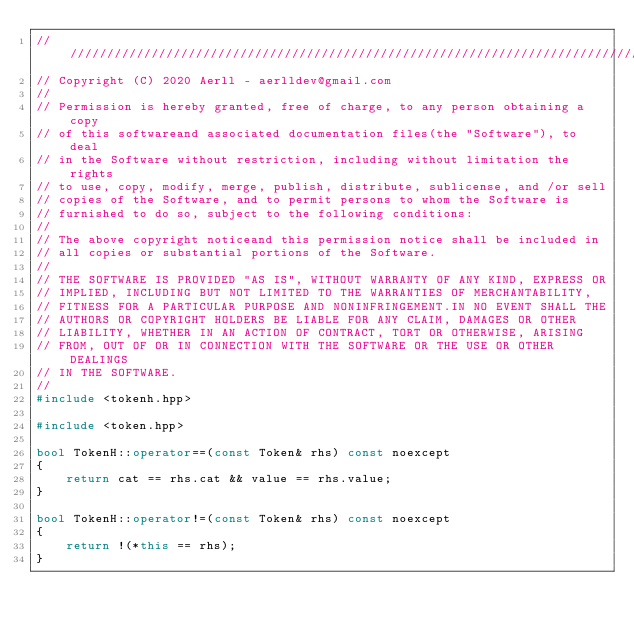<code> <loc_0><loc_0><loc_500><loc_500><_C++_>///////////////////////////////////////////////////////////////////////////////
// Copyright (C) 2020 Aerll - aerlldev@gmail.com
// 
// Permission is hereby granted, free of charge, to any person obtaining a copy
// of this softwareand associated documentation files(the "Software"), to deal
// in the Software without restriction, including without limitation the rights
// to use, copy, modify, merge, publish, distribute, sublicense, and /or sell
// copies of the Software, and to permit persons to whom the Software is
// furnished to do so, subject to the following conditions:
// 
// The above copyright noticeand this permission notice shall be included in
// all copies or substantial portions of the Software.
// 
// THE SOFTWARE IS PROVIDED "AS IS", WITHOUT WARRANTY OF ANY KIND, EXPRESS OR
// IMPLIED, INCLUDING BUT NOT LIMITED TO THE WARRANTIES OF MERCHANTABILITY,
// FITNESS FOR A PARTICULAR PURPOSE AND NONINFRINGEMENT.IN NO EVENT SHALL THE
// AUTHORS OR COPYRIGHT HOLDERS BE LIABLE FOR ANY CLAIM, DAMAGES OR OTHER
// LIABILITY, WHETHER IN AN ACTION OF CONTRACT, TORT OR OTHERWISE, ARISING
// FROM, OUT OF OR IN CONNECTION WITH THE SOFTWARE OR THE USE OR OTHER DEALINGS
// IN THE SOFTWARE.
//
#include <tokenh.hpp>

#include <token.hpp>

bool TokenH::operator==(const Token& rhs) const noexcept
{
    return cat == rhs.cat && value == rhs.value;
}

bool TokenH::operator!=(const Token& rhs) const noexcept
{
    return !(*this == rhs);
}
</code> 